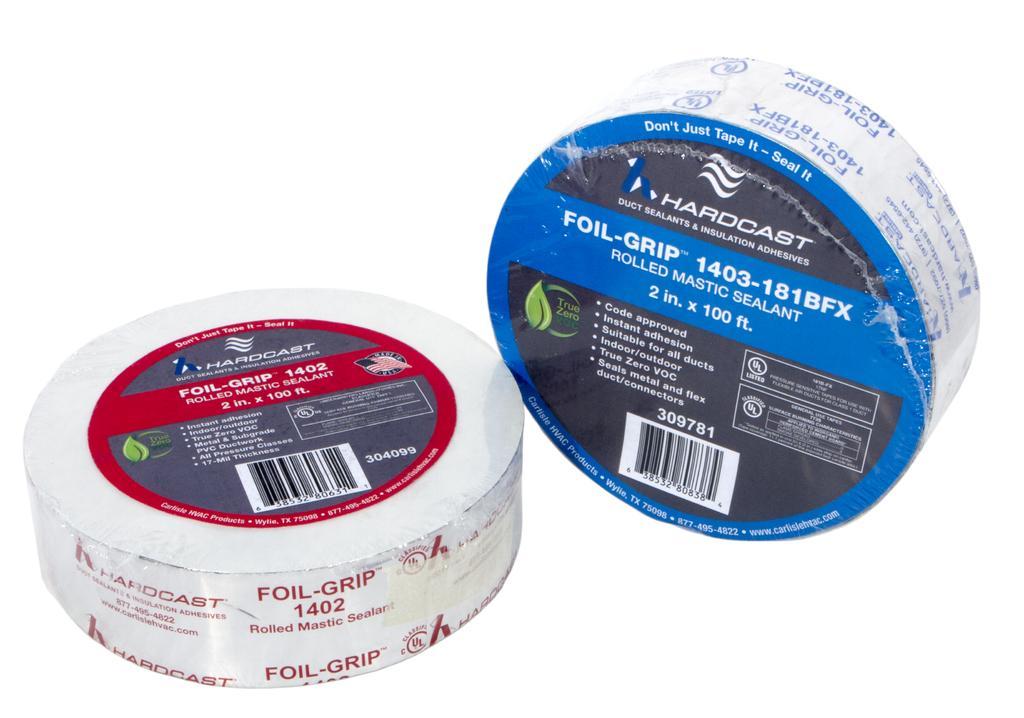How would you summarize this image in a sentence or two? The picture consists of two sealants on a white surface. 